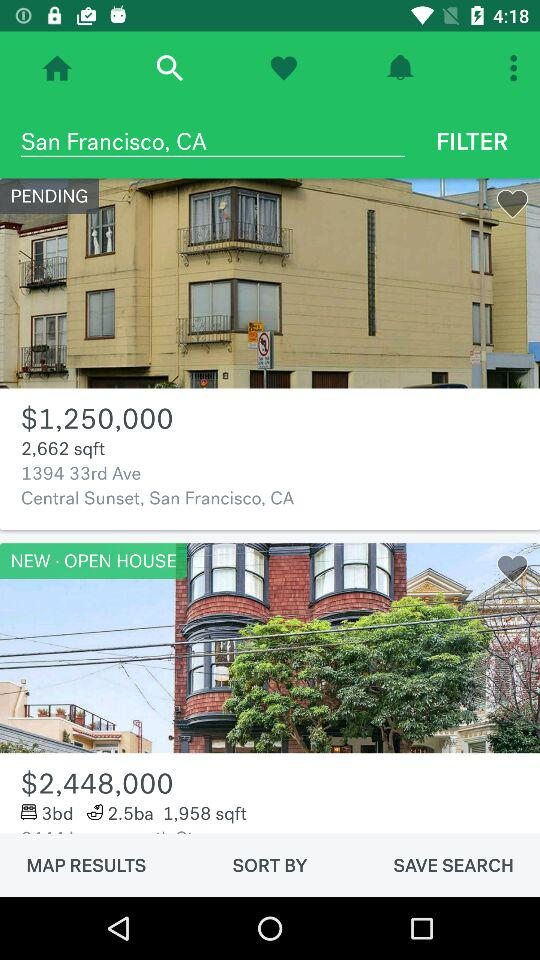What is the price of 1.958 sq ft? The price of 1.958 sq ft is $2,448,000. 